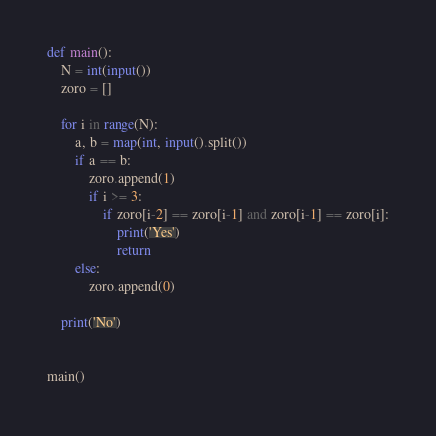<code> <loc_0><loc_0><loc_500><loc_500><_Python_>def main():
    N = int(input())
    zoro = []

    for i in range(N):
        a, b = map(int, input().split())
        if a == b:
            zoro.append(1)
            if i >= 3:
                if zoro[i-2] == zoro[i-1] and zoro[i-1] == zoro[i]:
                    print('Yes')
                    return
        else:
            zoro.append(0)

    print('No')


main()</code> 